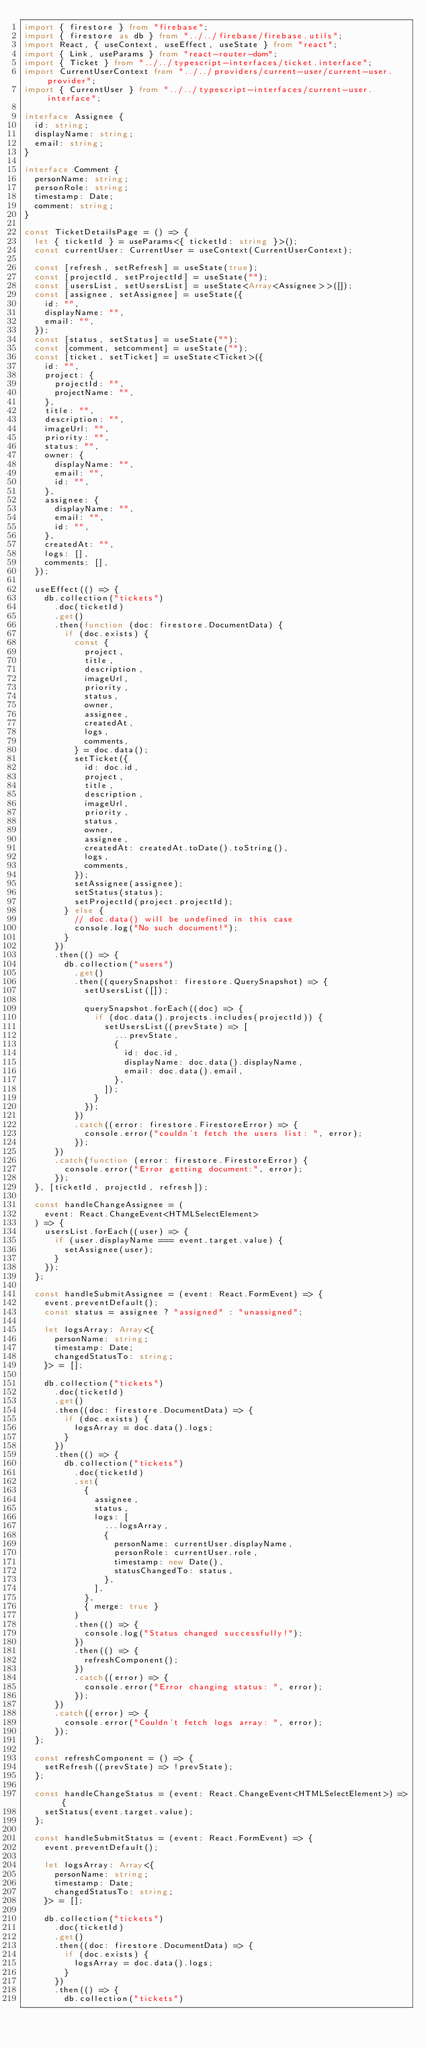Convert code to text. <code><loc_0><loc_0><loc_500><loc_500><_TypeScript_>import { firestore } from "firebase";
import { firestore as db } from "../../firebase/firebase.utils";
import React, { useContext, useEffect, useState } from "react";
import { Link, useParams } from "react-router-dom";
import { Ticket } from "../../typescript-interfaces/ticket.interface";
import CurrentUserContext from "../../providers/current-user/current-user.provider";
import { CurrentUser } from "../../typescript-interfaces/current-user.interface";

interface Assignee {
  id: string;
  displayName: string;
  email: string;
}

interface Comment {
  personName: string;
  personRole: string;
  timestamp: Date;
  comment: string;
}

const TicketDetailsPage = () => {
  let { ticketId } = useParams<{ ticketId: string }>();
  const currentUser: CurrentUser = useContext(CurrentUserContext);

  const [refresh, setRefresh] = useState(true);
  const [projectId, setProjectId] = useState("");
  const [usersList, setUsersList] = useState<Array<Assignee>>([]);
  const [assignee, setAssignee] = useState({
    id: "",
    displayName: "",
    email: "",
  });
  const [status, setStatus] = useState("");
  const [comment, setcomment] = useState("");
  const [ticket, setTicket] = useState<Ticket>({
    id: "",
    project: {
      projectId: "",
      projectName: "",
    },
    title: "",
    description: "",
    imageUrl: "",
    priority: "",
    status: "",
    owner: {
      displayName: "",
      email: "",
      id: "",
    },
    assignee: {
      displayName: "",
      email: "",
      id: "",
    },
    createdAt: "",
    logs: [],
    comments: [],
  });

  useEffect(() => {
    db.collection("tickets")
      .doc(ticketId)
      .get()
      .then(function (doc: firestore.DocumentData) {
        if (doc.exists) {
          const {
            project,
            title,
            description,
            imageUrl,
            priority,
            status,
            owner,
            assignee,
            createdAt,
            logs,
            comments,
          } = doc.data();
          setTicket({
            id: doc.id,
            project,
            title,
            description,
            imageUrl,
            priority,
            status,
            owner,
            assignee,
            createdAt: createdAt.toDate().toString(),
            logs,
            comments,
          });
          setAssignee(assignee);
          setStatus(status);
          setProjectId(project.projectId);
        } else {
          // doc.data() will be undefined in this case
          console.log("No such document!");
        }
      })
      .then(() => {
        db.collection("users")
          .get()
          .then((querySnapshot: firestore.QuerySnapshot) => {
            setUsersList([]);

            querySnapshot.forEach((doc) => {
              if (doc.data().projects.includes(projectId)) {
                setUsersList((prevState) => [
                  ...prevState,
                  {
                    id: doc.id,
                    displayName: doc.data().displayName,
                    email: doc.data().email,
                  },
                ]);
              }
            });
          })
          .catch((error: firestore.FirestoreError) => {
            console.error("couldn't fetch the users list: ", error);
          });
      })
      .catch(function (error: firestore.FirestoreError) {
        console.error("Error getting document:", error);
      });
  }, [ticketId, projectId, refresh]);

  const handleChangeAssignee = (
    event: React.ChangeEvent<HTMLSelectElement>
  ) => {
    usersList.forEach((user) => {
      if (user.displayName === event.target.value) {
        setAssignee(user);
      }
    });
  };

  const handleSubmitAssignee = (event: React.FormEvent) => {
    event.preventDefault();
    const status = assignee ? "assigned" : "unassigned";

    let logsArray: Array<{
      personName: string;
      timestamp: Date;
      changedStatusTo: string;
    }> = [];

    db.collection("tickets")
      .doc(ticketId)
      .get()
      .then((doc: firestore.DocumentData) => {
        if (doc.exists) {
          logsArray = doc.data().logs;
        }
      })
      .then(() => {
        db.collection("tickets")
          .doc(ticketId)
          .set(
            {
              assignee,
              status,
              logs: [
                ...logsArray,
                {
                  personName: currentUser.displayName,
                  personRole: currentUser.role,
                  timestamp: new Date(),
                  statusChangedTo: status,
                },
              ],
            },
            { merge: true }
          )
          .then(() => {
            console.log("Status changed successfully!");
          })
          .then(() => {
            refreshComponent();
          })
          .catch((error) => {
            console.error("Error changing status: ", error);
          });
      })
      .catch((error) => {
        console.error("Couldn't fetch logs array: ", error);
      });
  };

  const refreshComponent = () => {
    setRefresh((prevState) => !prevState);
  };

  const handleChangeStatus = (event: React.ChangeEvent<HTMLSelectElement>) => {
    setStatus(event.target.value);
  };

  const handleSubmitStatus = (event: React.FormEvent) => {
    event.preventDefault();

    let logsArray: Array<{
      personName: string;
      timestamp: Date;
      changedStatusTo: string;
    }> = [];

    db.collection("tickets")
      .doc(ticketId)
      .get()
      .then((doc: firestore.DocumentData) => {
        if (doc.exists) {
          logsArray = doc.data().logs;
        }
      })
      .then(() => {
        db.collection("tickets")</code> 